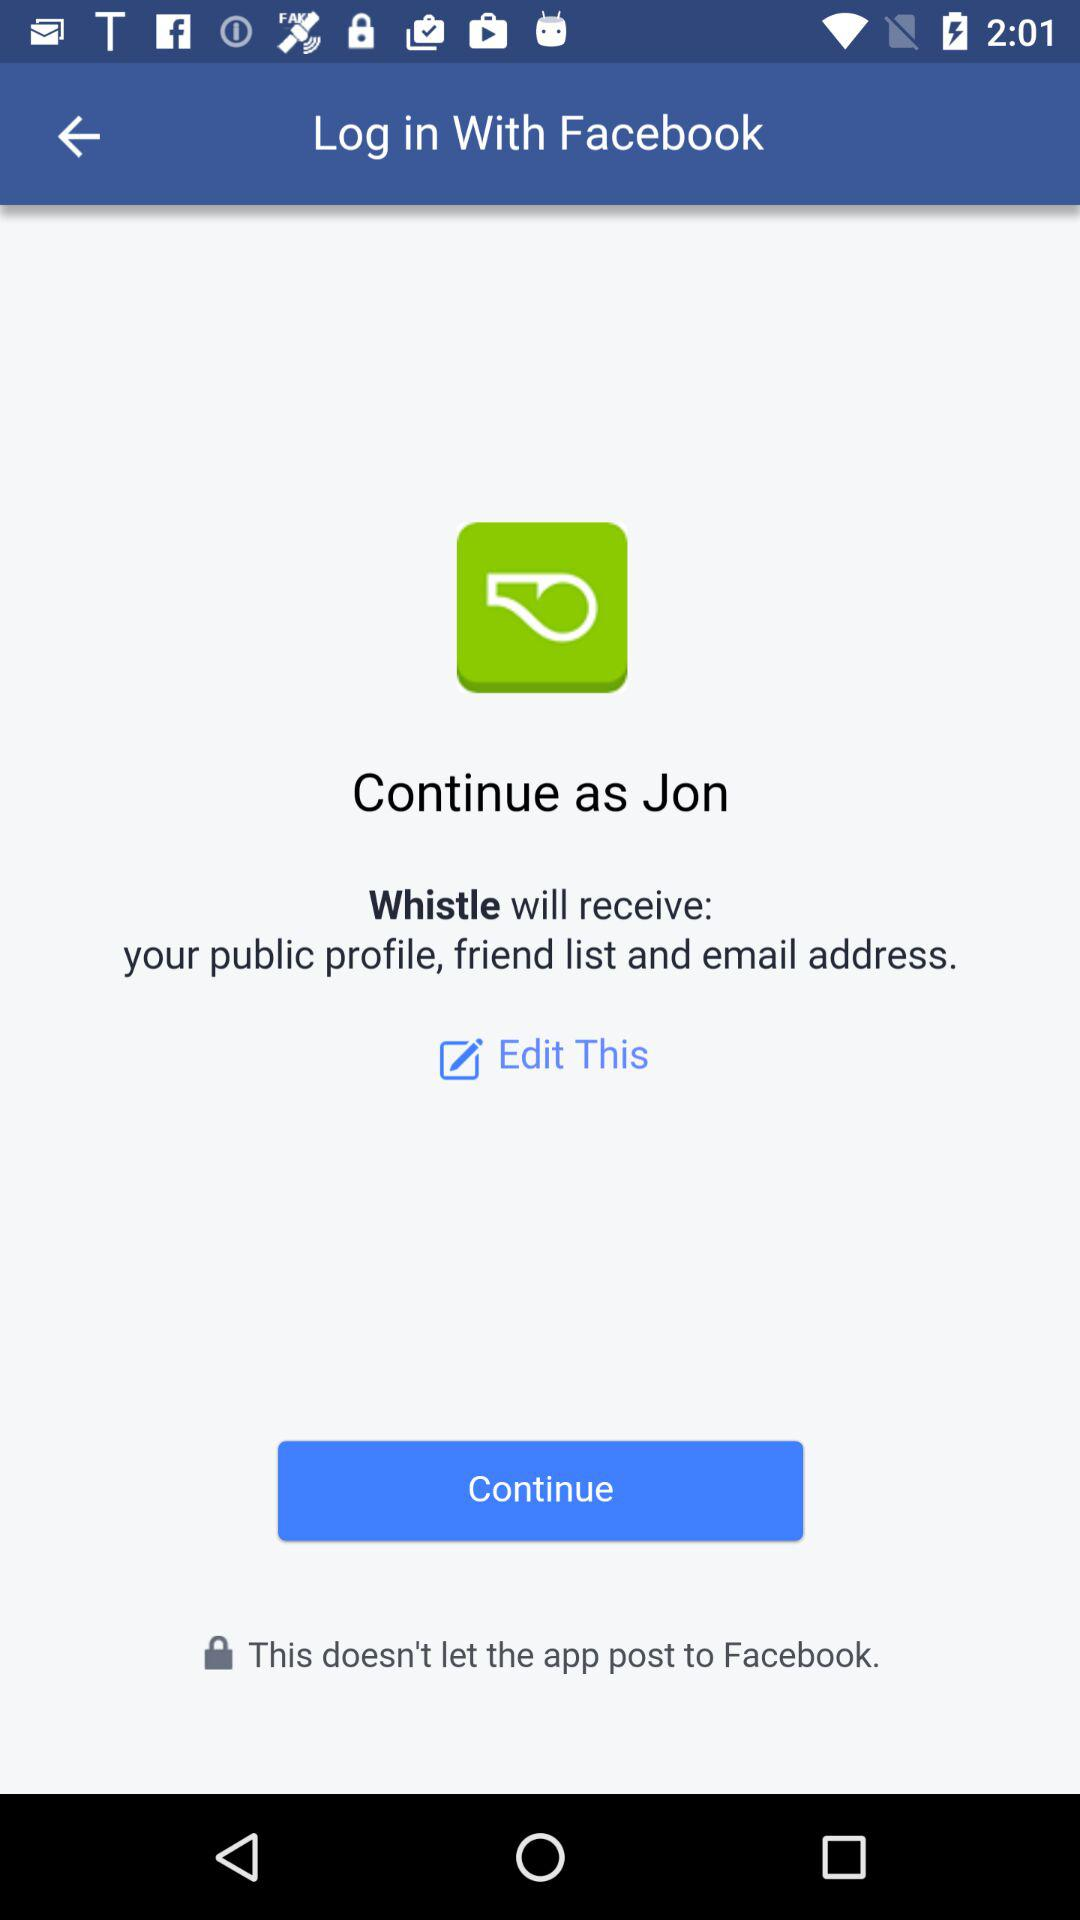What is the user name? The user name is Jon. 